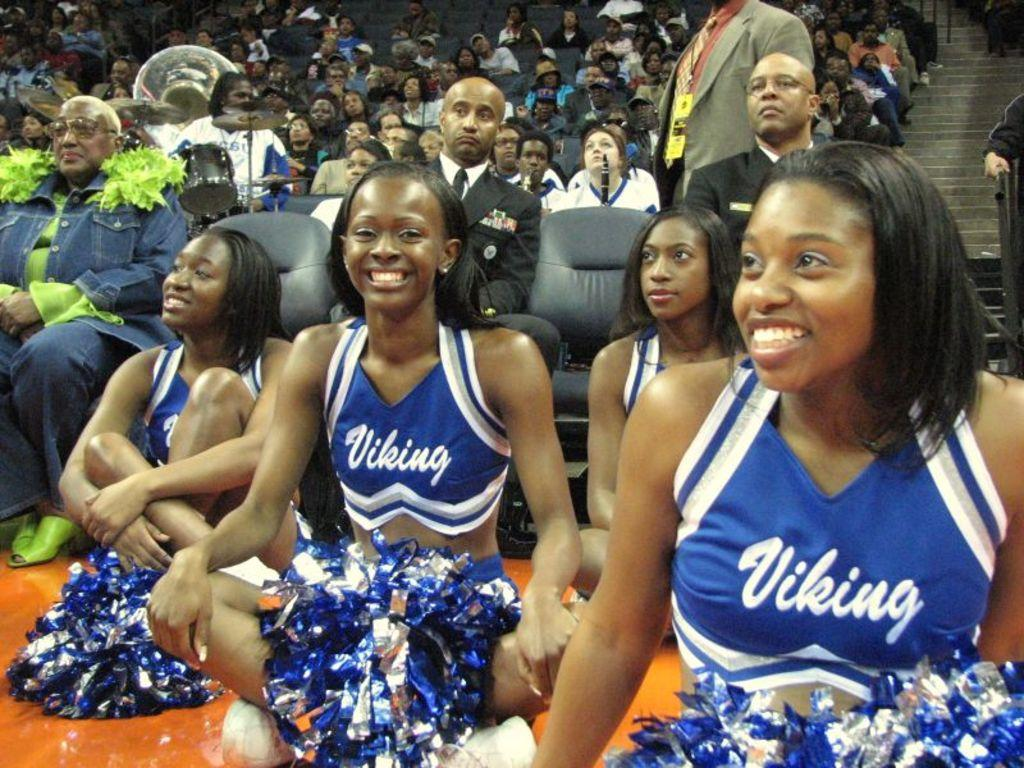Provide a one-sentence caption for the provided image. Four black Viking cheerleaders sitting on the floor of an arena. 